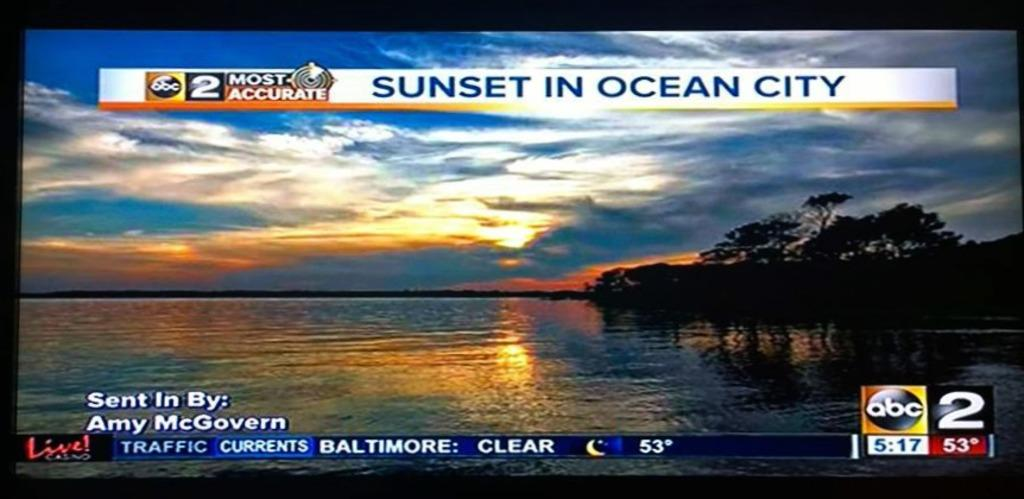<image>
Present a compact description of the photo's key features. A TV screen featuring a sunset in Ocean City. 